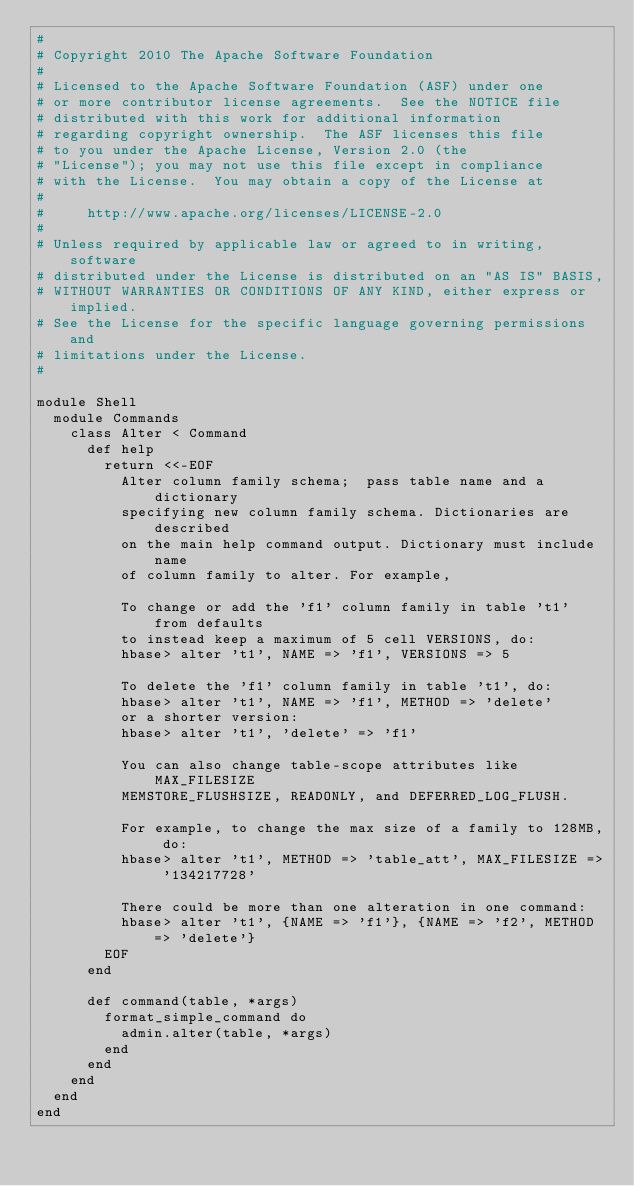Convert code to text. <code><loc_0><loc_0><loc_500><loc_500><_Ruby_>#
# Copyright 2010 The Apache Software Foundation
#
# Licensed to the Apache Software Foundation (ASF) under one
# or more contributor license agreements.  See the NOTICE file
# distributed with this work for additional information
# regarding copyright ownership.  The ASF licenses this file
# to you under the Apache License, Version 2.0 (the
# "License"); you may not use this file except in compliance
# with the License.  You may obtain a copy of the License at
#
#     http://www.apache.org/licenses/LICENSE-2.0
#
# Unless required by applicable law or agreed to in writing, software
# distributed under the License is distributed on an "AS IS" BASIS,
# WITHOUT WARRANTIES OR CONDITIONS OF ANY KIND, either express or implied.
# See the License for the specific language governing permissions and
# limitations under the License.
#

module Shell
  module Commands
    class Alter < Command
      def help
        return <<-EOF
          Alter column family schema;  pass table name and a dictionary
          specifying new column family schema. Dictionaries are described
          on the main help command output. Dictionary must include name
          of column family to alter. For example,

          To change or add the 'f1' column family in table 't1' from defaults
          to instead keep a maximum of 5 cell VERSIONS, do:
          hbase> alter 't1', NAME => 'f1', VERSIONS => 5

          To delete the 'f1' column family in table 't1', do:
          hbase> alter 't1', NAME => 'f1', METHOD => 'delete'
          or a shorter version:
          hbase> alter 't1', 'delete' => 'f1'

          You can also change table-scope attributes like MAX_FILESIZE
          MEMSTORE_FLUSHSIZE, READONLY, and DEFERRED_LOG_FLUSH.

          For example, to change the max size of a family to 128MB, do:
          hbase> alter 't1', METHOD => 'table_att', MAX_FILESIZE => '134217728'

          There could be more than one alteration in one command:
          hbase> alter 't1', {NAME => 'f1'}, {NAME => 'f2', METHOD => 'delete'}
        EOF
      end

      def command(table, *args)
        format_simple_command do
          admin.alter(table, *args)
        end
      end
    end
  end
end
</code> 